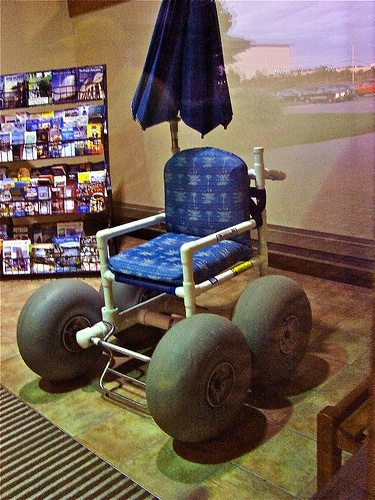Describe the objects in this image and their specific colors. I can see chair in tan, black, navy, and gray tones, umbrella in tan, black, navy, maroon, and purple tones, chair in tan, maroon, black, and gray tones, book in tan, black, lightgray, gray, and darkgray tones, and book in tan, white, violet, darkgray, and purple tones in this image. 